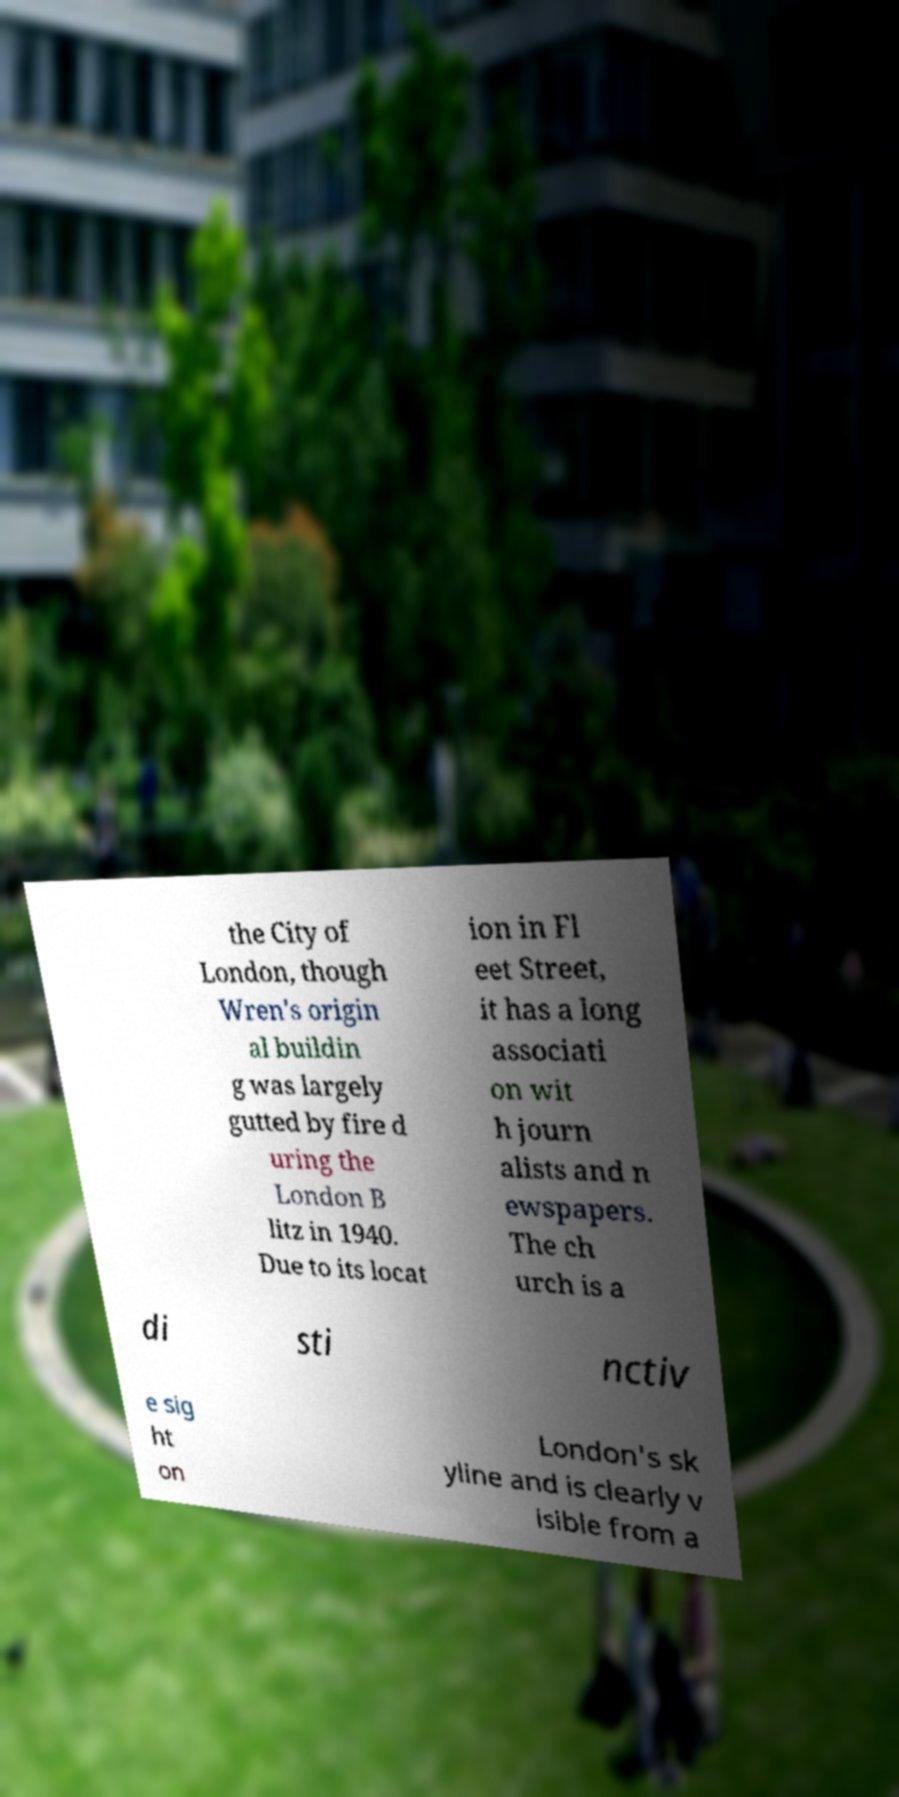For documentation purposes, I need the text within this image transcribed. Could you provide that? the City of London, though Wren's origin al buildin g was largely gutted by fire d uring the London B litz in 1940. Due to its locat ion in Fl eet Street, it has a long associati on wit h journ alists and n ewspapers. The ch urch is a di sti nctiv e sig ht on London's sk yline and is clearly v isible from a 